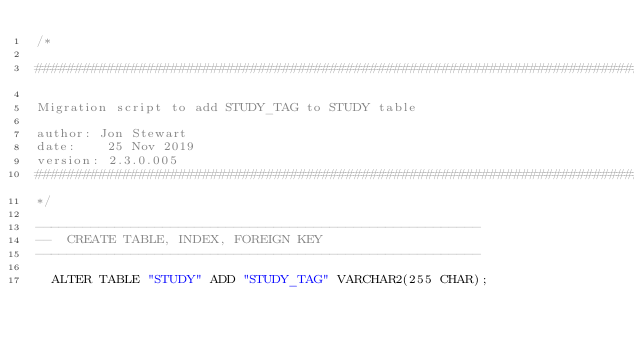<code> <loc_0><loc_0><loc_500><loc_500><_SQL_>/*

################################################################################

Migration script to add STUDY_TAG to STUDY table

author: Jon Stewart
date:    25 Nov 2019
version: 2.3.0.005
################################################################################
*/

--------------------------------------------------------
--  CREATE TABLE, INDEX, FOREIGN KEY
--------------------------------------------------------

  ALTER TABLE "STUDY" ADD "STUDY_TAG" VARCHAR2(255 CHAR);
</code> 